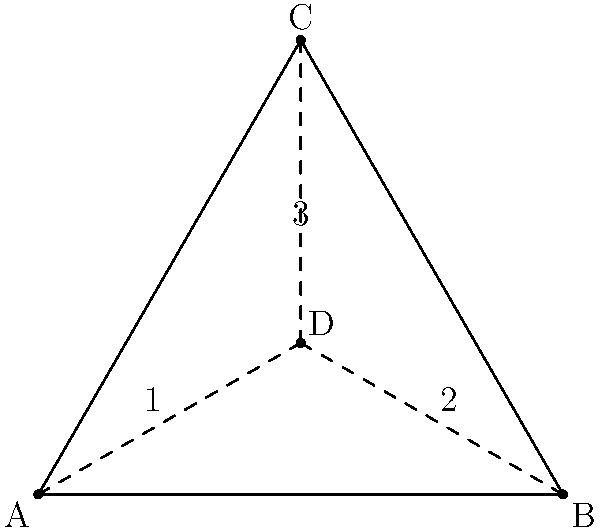In a community project planning diagram, you've created a triangular representation of three interconnected initiatives, with a central point representing shared resources. The diagram has rotational and reflection symmetries. How many elements are in the symmetry group of this diagram? To determine the number of elements in the symmetry group, we need to identify all the symmetries of the diagram:

1. Rotational symmetries:
   - Identity (rotation by 0°)
   - Rotation by 120° clockwise
   - Rotation by 240° clockwise (or 120° counterclockwise)

2. Reflection symmetries:
   - Reflection across the line AD
   - Reflection across the line BD
   - Reflection across the line CD

The symmetry group consists of all these transformations that preserve the structure of the diagram. 

To count the elements:
- 3 rotational symmetries
- 3 reflection symmetries

Therefore, the total number of elements in the symmetry group is 3 + 3 = 6.

This group is isomorphic to the dihedral group $D_3$, which is the symmetry group of an equilateral triangle.
Answer: 6 